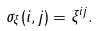Convert formula to latex. <formula><loc_0><loc_0><loc_500><loc_500>\sigma _ { \xi } ( i , j ) = \xi ^ { i j } .</formula> 